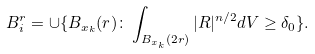Convert formula to latex. <formula><loc_0><loc_0><loc_500><loc_500>B _ { i } ^ { r } = \cup \{ B _ { x _ { k } } ( r ) \colon \int _ { B _ { x _ { k } } ( 2 r ) } | R | ^ { n / 2 } d V \geq \delta _ { 0 } \} .</formula> 